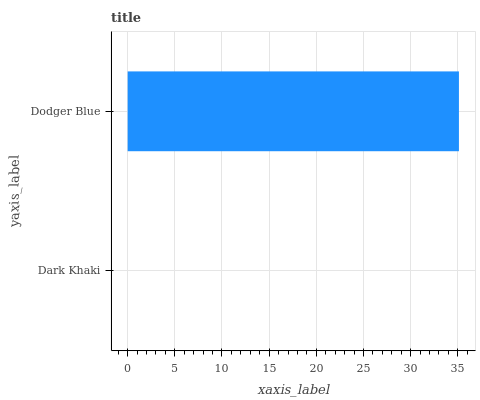Is Dark Khaki the minimum?
Answer yes or no. Yes. Is Dodger Blue the maximum?
Answer yes or no. Yes. Is Dodger Blue the minimum?
Answer yes or no. No. Is Dodger Blue greater than Dark Khaki?
Answer yes or no. Yes. Is Dark Khaki less than Dodger Blue?
Answer yes or no. Yes. Is Dark Khaki greater than Dodger Blue?
Answer yes or no. No. Is Dodger Blue less than Dark Khaki?
Answer yes or no. No. Is Dodger Blue the high median?
Answer yes or no. Yes. Is Dark Khaki the low median?
Answer yes or no. Yes. Is Dark Khaki the high median?
Answer yes or no. No. Is Dodger Blue the low median?
Answer yes or no. No. 